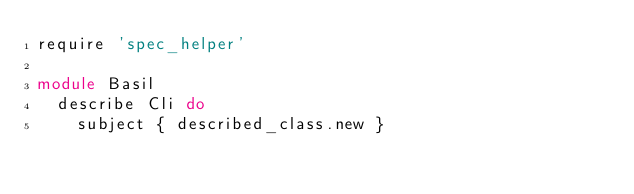Convert code to text. <code><loc_0><loc_0><loc_500><loc_500><_Ruby_>require 'spec_helper'

module Basil
  describe Cli do
    subject { described_class.new }
</code> 